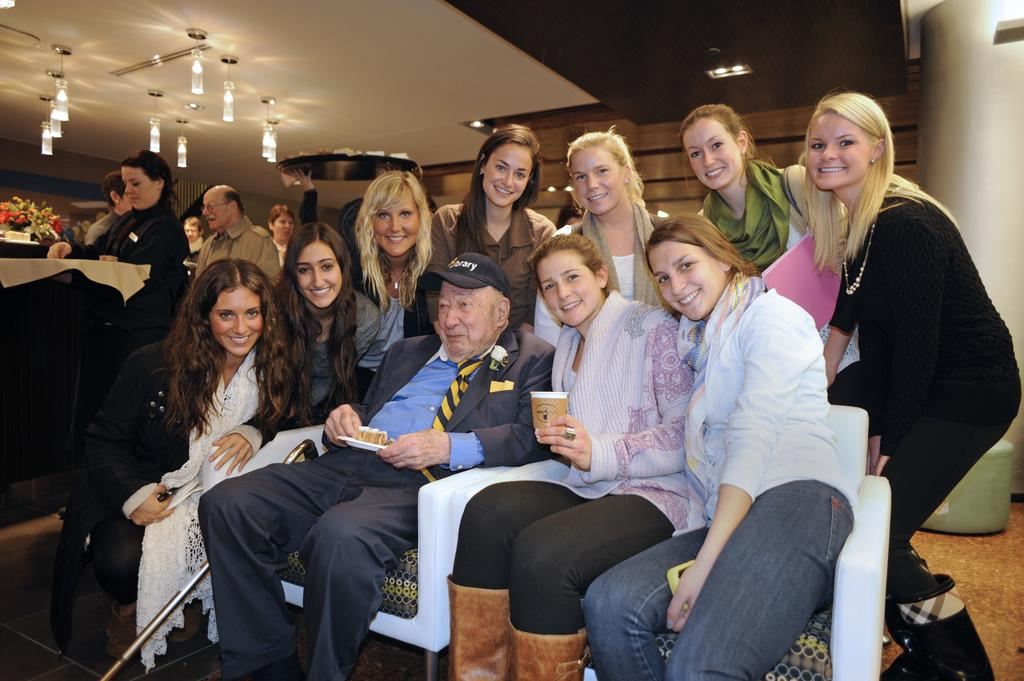How many people are sitting on chairs in the image? There are three people sitting on chairs in the image. What is happening in the background of the image? There are people standing in the background of the image. What structure is visible in the image? There is a roof visible in the image. What can be used for illumination in the image? There are lights in the image. What type of foot is visible on the stage in the image? There is no stage or foot present in the image. What kind of flesh can be seen on the people in the image? The image does not show any flesh; it only shows people sitting on chairs and standing in the background. 